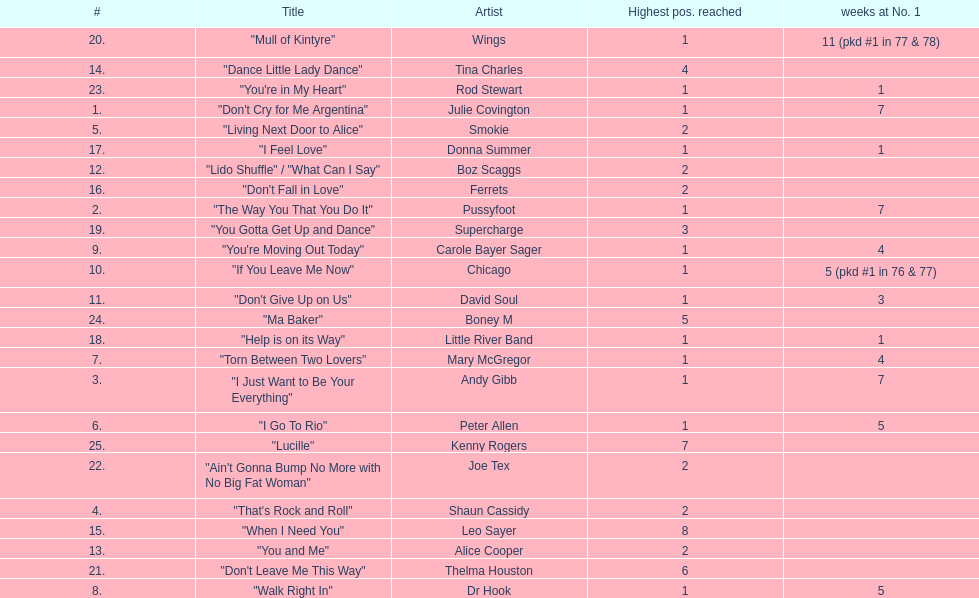Which song stayed at no.1 for the most amount of weeks. "Mull of Kintyre". 